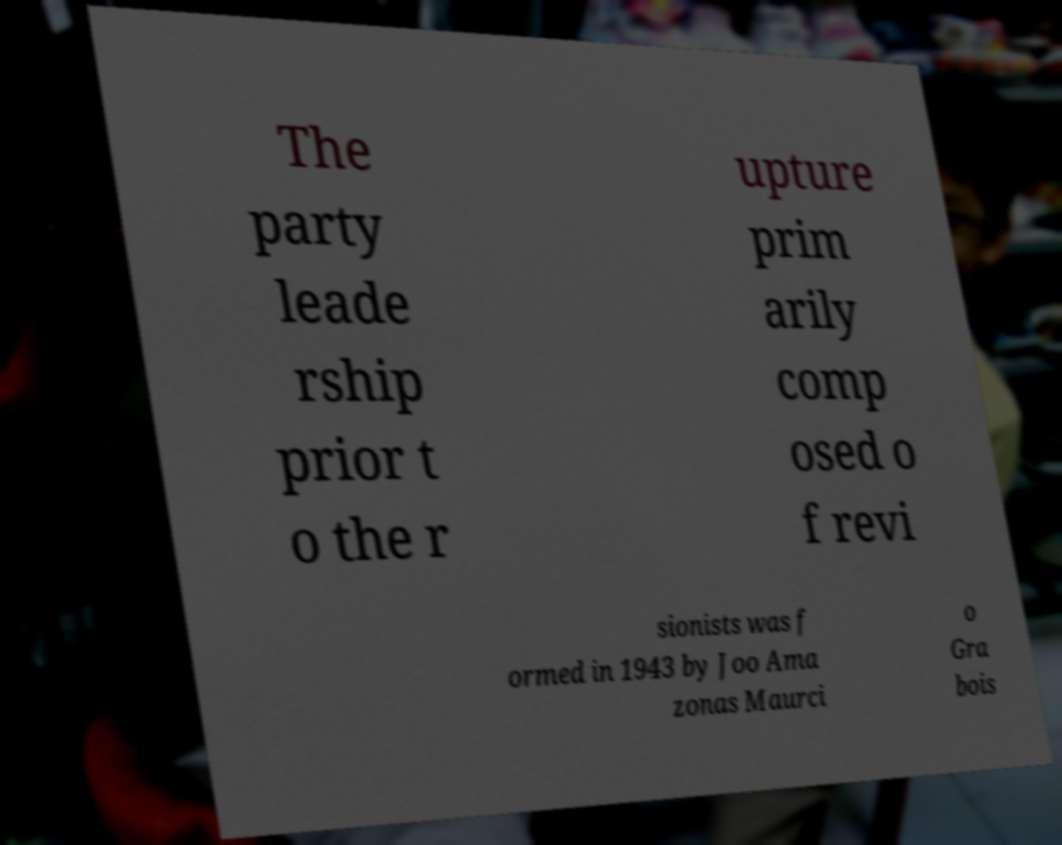Please read and relay the text visible in this image. What does it say? The party leade rship prior t o the r upture prim arily comp osed o f revi sionists was f ormed in 1943 by Joo Ama zonas Maurci o Gra bois 